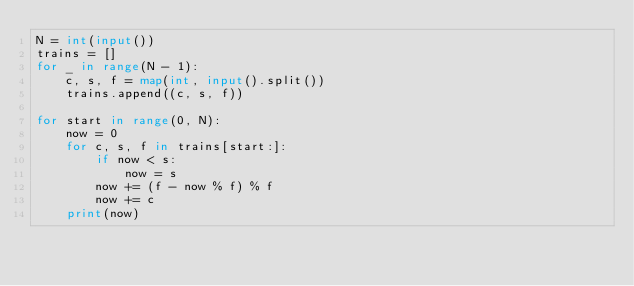Convert code to text. <code><loc_0><loc_0><loc_500><loc_500><_Python_>N = int(input())
trains = []
for _ in range(N - 1):
    c, s, f = map(int, input().split())
    trains.append((c, s, f))

for start in range(0, N):
    now = 0
    for c, s, f in trains[start:]:
        if now < s:
            now = s
        now += (f - now % f) % f
        now += c
    print(now)
</code> 